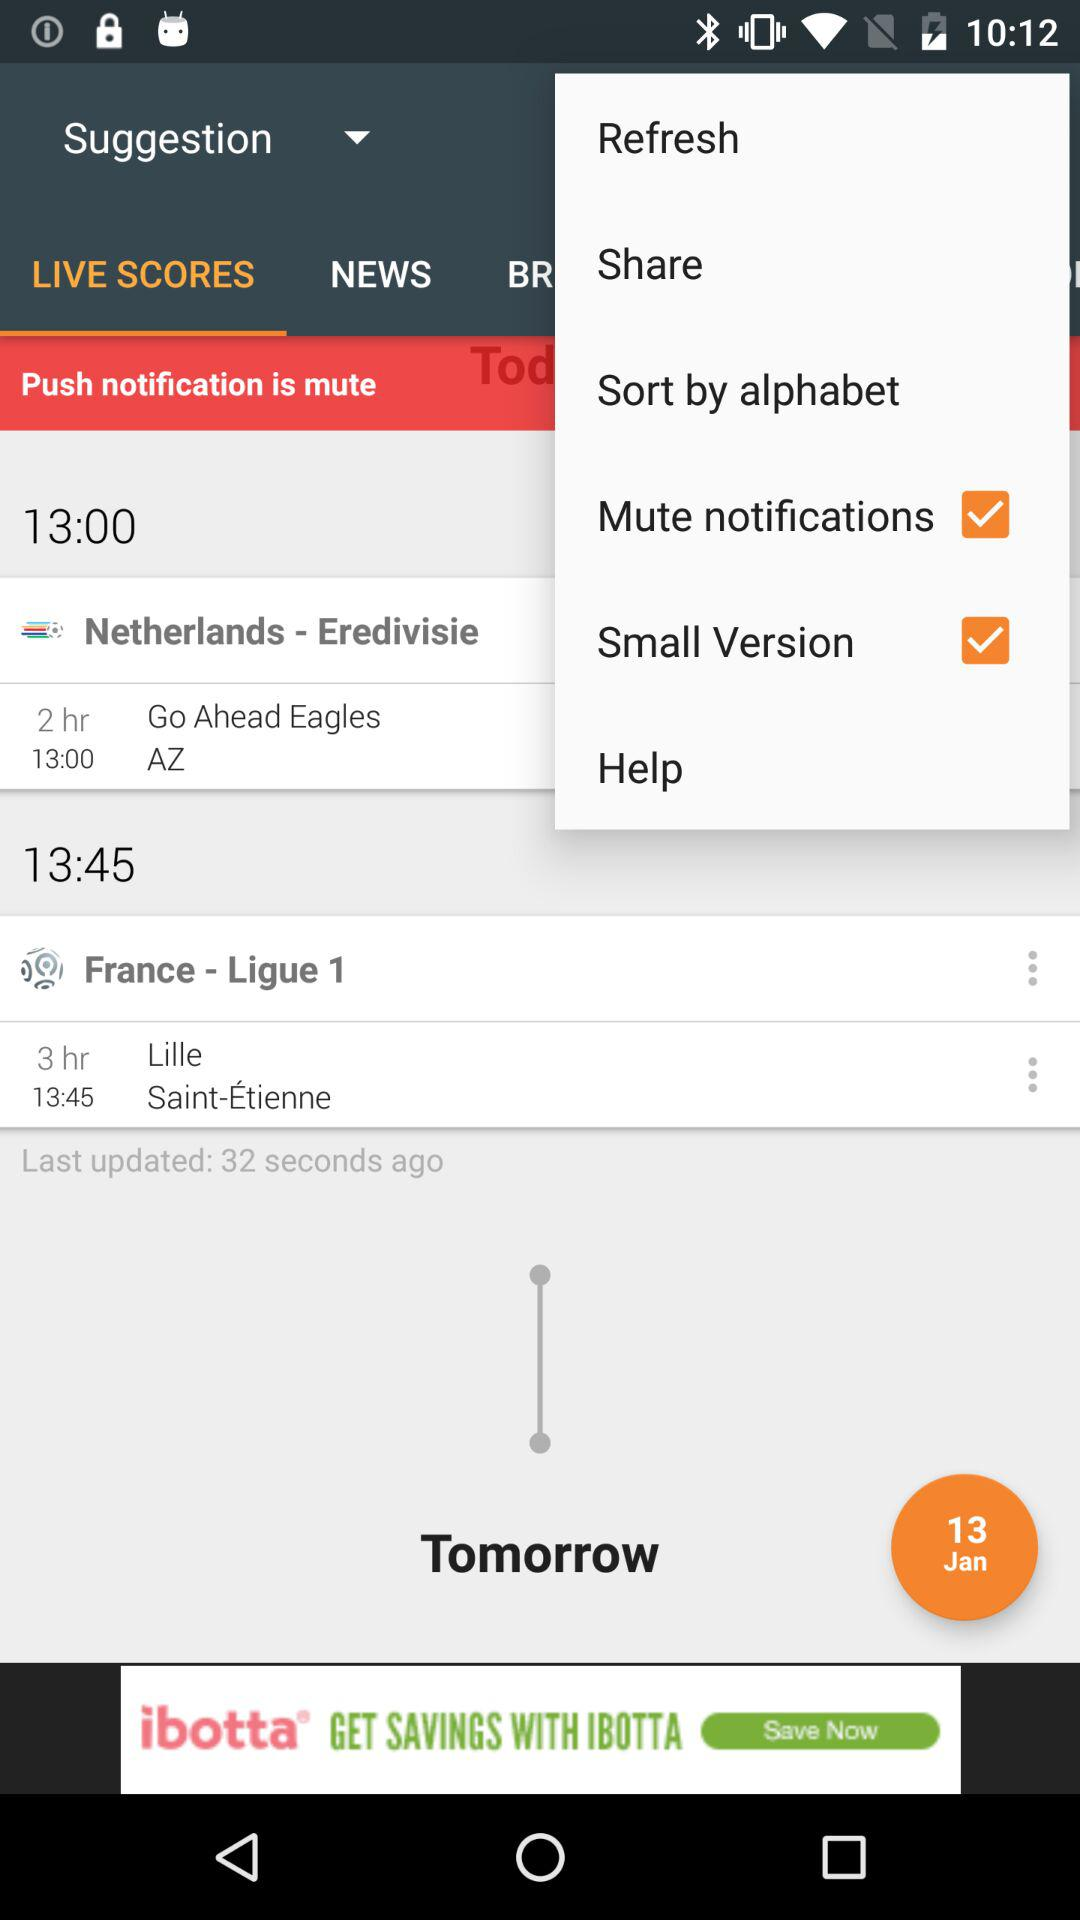Which tab is selected? The selected tab is "LIVE SCORES". 